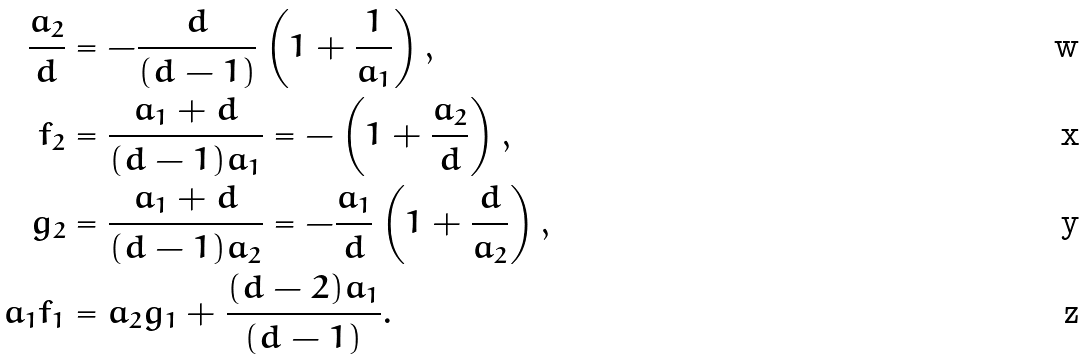Convert formula to latex. <formula><loc_0><loc_0><loc_500><loc_500>\frac { a _ { 2 } } { d } & = - \frac { d } { ( d - 1 ) } \left ( 1 + \frac { 1 } { a _ { 1 } } \right ) , \\ f _ { 2 } & = \frac { a _ { 1 } + d } { ( d - 1 ) a _ { 1 } } = - \left ( 1 + \frac { a _ { 2 } } { d } \right ) , \\ g _ { 2 } & = \frac { a _ { 1 } + d } { ( d - 1 ) a _ { 2 } } = - \frac { a _ { 1 } } { d } \left ( 1 + \frac { d } { a _ { 2 } } \right ) , \\ a _ { 1 } f _ { 1 } & = a _ { 2 } g _ { 1 } + \frac { ( d - 2 ) a _ { 1 } } { ( d - 1 ) } .</formula> 